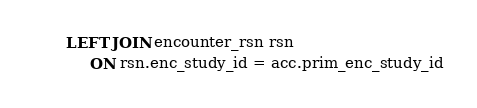<code> <loc_0><loc_0><loc_500><loc_500><_SQL_>       LEFT JOIN encounter_rsn rsn
            ON rsn.enc_study_id = acc.prim_enc_study_id
</code> 